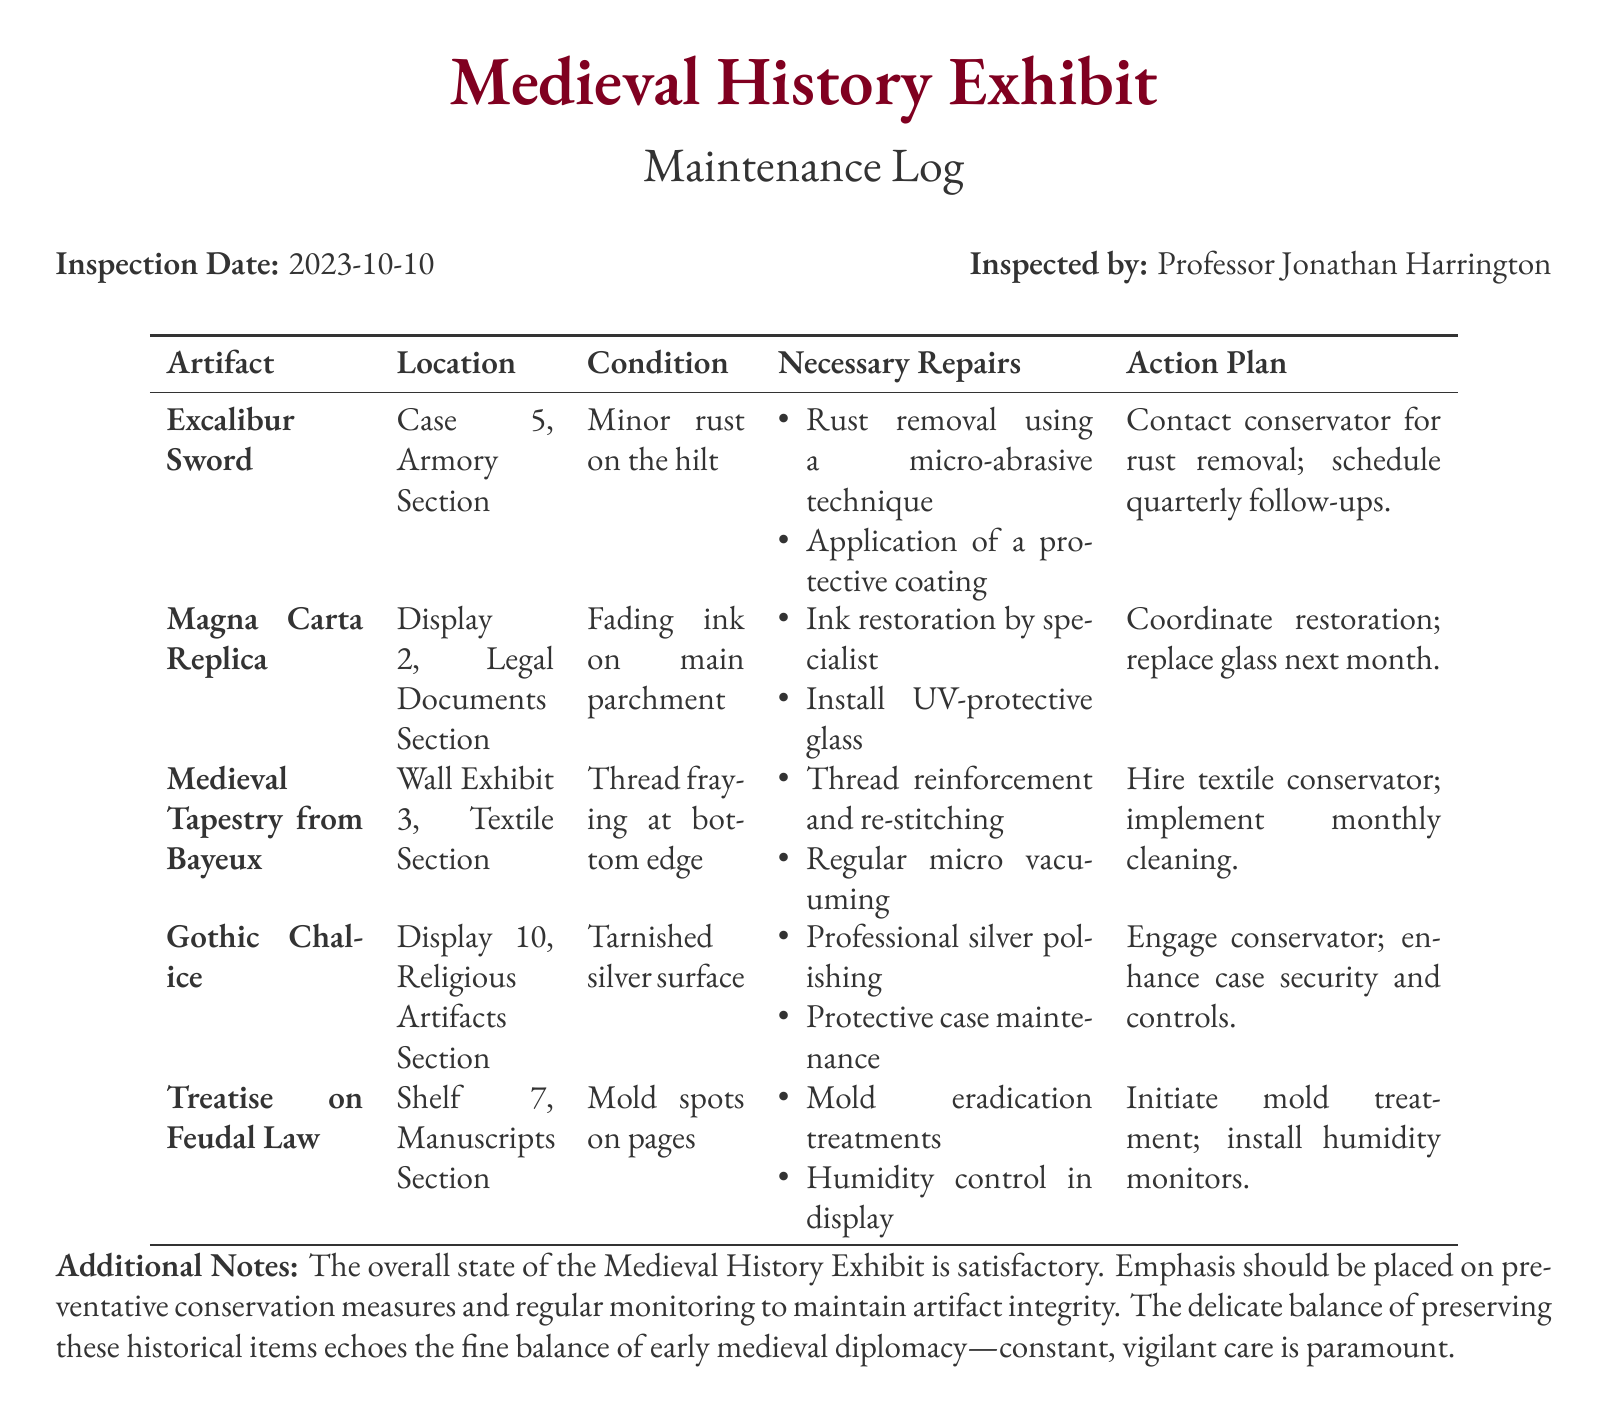What is the inspection date? The inspection date is specifically mentioned in the document, which is 2023-10-10.
Answer: 2023-10-10 Who inspected the artifacts? The inspector's name is provided in the document as the person who conducted the inspection.
Answer: Professor Jonathan Harrington What is the condition of the Excalibur Sword? The document states the condition of each artifact, including the Excalibur Sword, which is described.
Answer: Minor rust on the hilt What repair is needed for the Magna Carta Replica? The necessary repairs for each artifact are listed, including the Magna Carta Replica.
Answer: Ink restoration by specialist What action is planned for the Gothic Chalice? The action plans indicate what will be done regarding each artifact, specifically for the Gothic Chalice.
Answer: Engage conservator; enhance case security and controls Which artifact is located in the Armory Section? Each artifact's location is provided, including the one in the Armory Section.
Answer: Excalibur Sword What type of cleaning is recommended for the Medieval Tapestry from Bayeux? The necessary repairs include ongoing care practices, including cleaning methods suggested for the tapestry.
Answer: Regular micro vacuuming How many artifacts are mentioned in the log? The total count of artifacts listed in the long table section provides this information directly.
Answer: Five What is one of the additional notes about the overall state of the exhibit? The additional notes section summarizes key aspects of the exhibit's condition and care requirements.
Answer: Emphasis should be placed on preventative conservation measures 